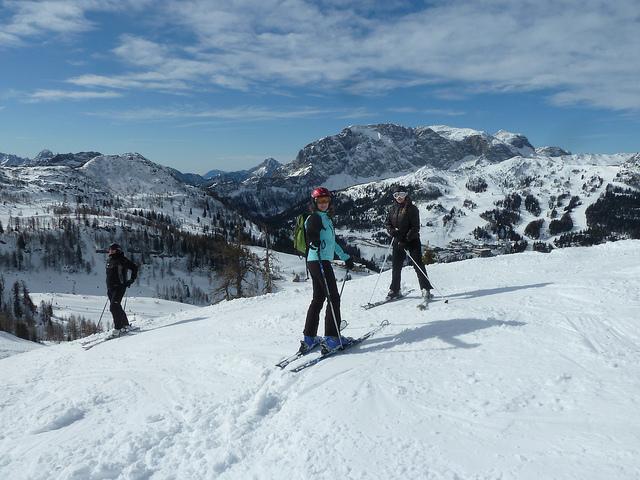How many people is in the picture?
Give a very brief answer. 3. How many people can you see?
Give a very brief answer. 2. 